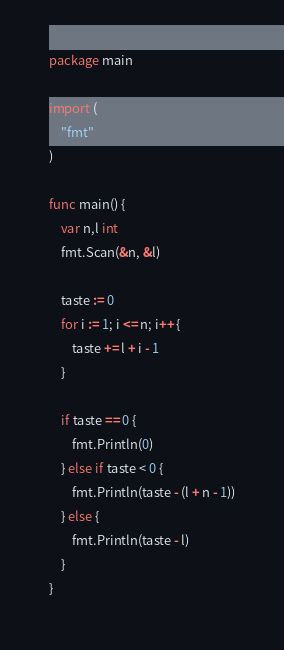Convert code to text. <code><loc_0><loc_0><loc_500><loc_500><_Go_>package main

import (
	"fmt"
)

func main() {
	var n,l int
	fmt.Scan(&n, &l)

	taste := 0
	for i := 1; i <= n; i++ {
		taste += l + i - 1
	}

	if taste == 0 {
		fmt.Println(0)
	} else if taste < 0 {
		fmt.Println(taste - (l + n - 1))
	} else {
		fmt.Println(taste - l)
	}
}</code> 